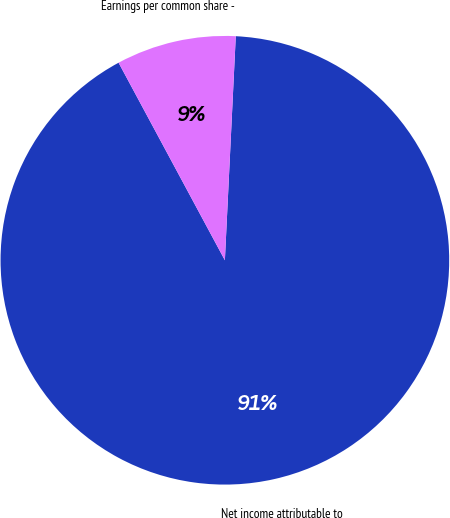<chart> <loc_0><loc_0><loc_500><loc_500><pie_chart><fcel>Net income attributable to<fcel>Earnings per common share -<nl><fcel>91.37%<fcel>8.63%<nl></chart> 